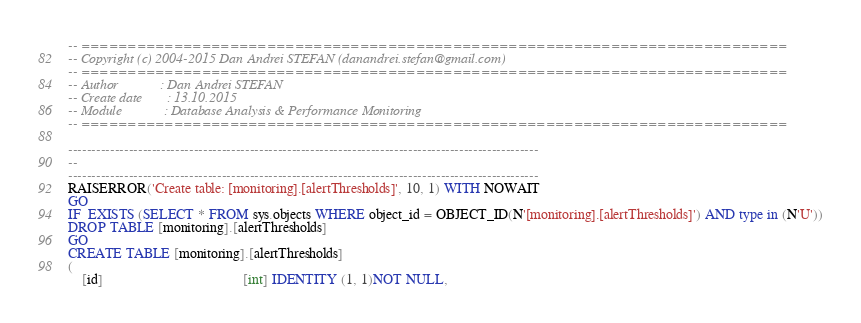<code> <loc_0><loc_0><loc_500><loc_500><_SQL_>-- ============================================================================
-- Copyright (c) 2004-2015 Dan Andrei STEFAN (danandrei.stefan@gmail.com)
-- ============================================================================
-- Author			 : Dan Andrei STEFAN
-- Create date		 : 13.10.2015
-- Module			 : Database Analysis & Performance Monitoring
-- ============================================================================

-----------------------------------------------------------------------------------------------------
--
-----------------------------------------------------------------------------------------------------
RAISERROR('Create table: [monitoring].[alertThresholds]', 10, 1) WITH NOWAIT
GO
IF  EXISTS (SELECT * FROM sys.objects WHERE object_id = OBJECT_ID(N'[monitoring].[alertThresholds]') AND type in (N'U'))
DROP TABLE [monitoring].[alertThresholds]
GO
CREATE TABLE [monitoring].[alertThresholds]
(
	[id]										[int] IDENTITY (1, 1)NOT NULL,</code> 